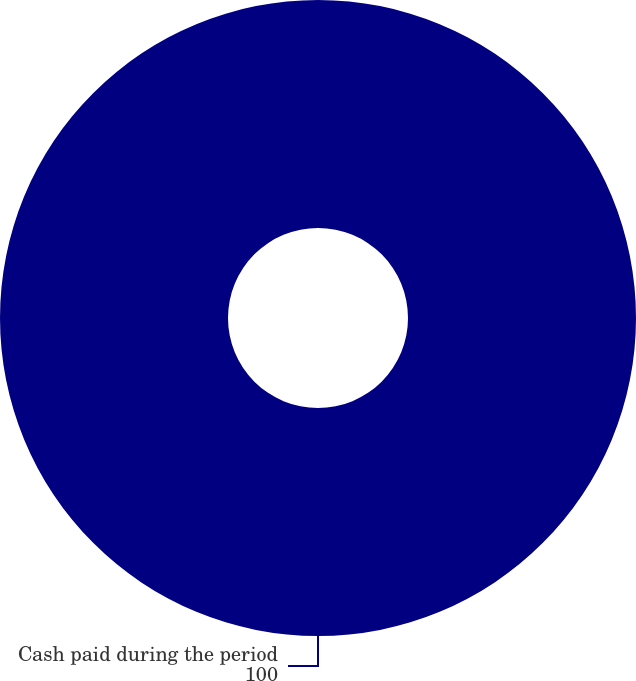Convert chart. <chart><loc_0><loc_0><loc_500><loc_500><pie_chart><fcel>Cash paid during the period<nl><fcel>100.0%<nl></chart> 